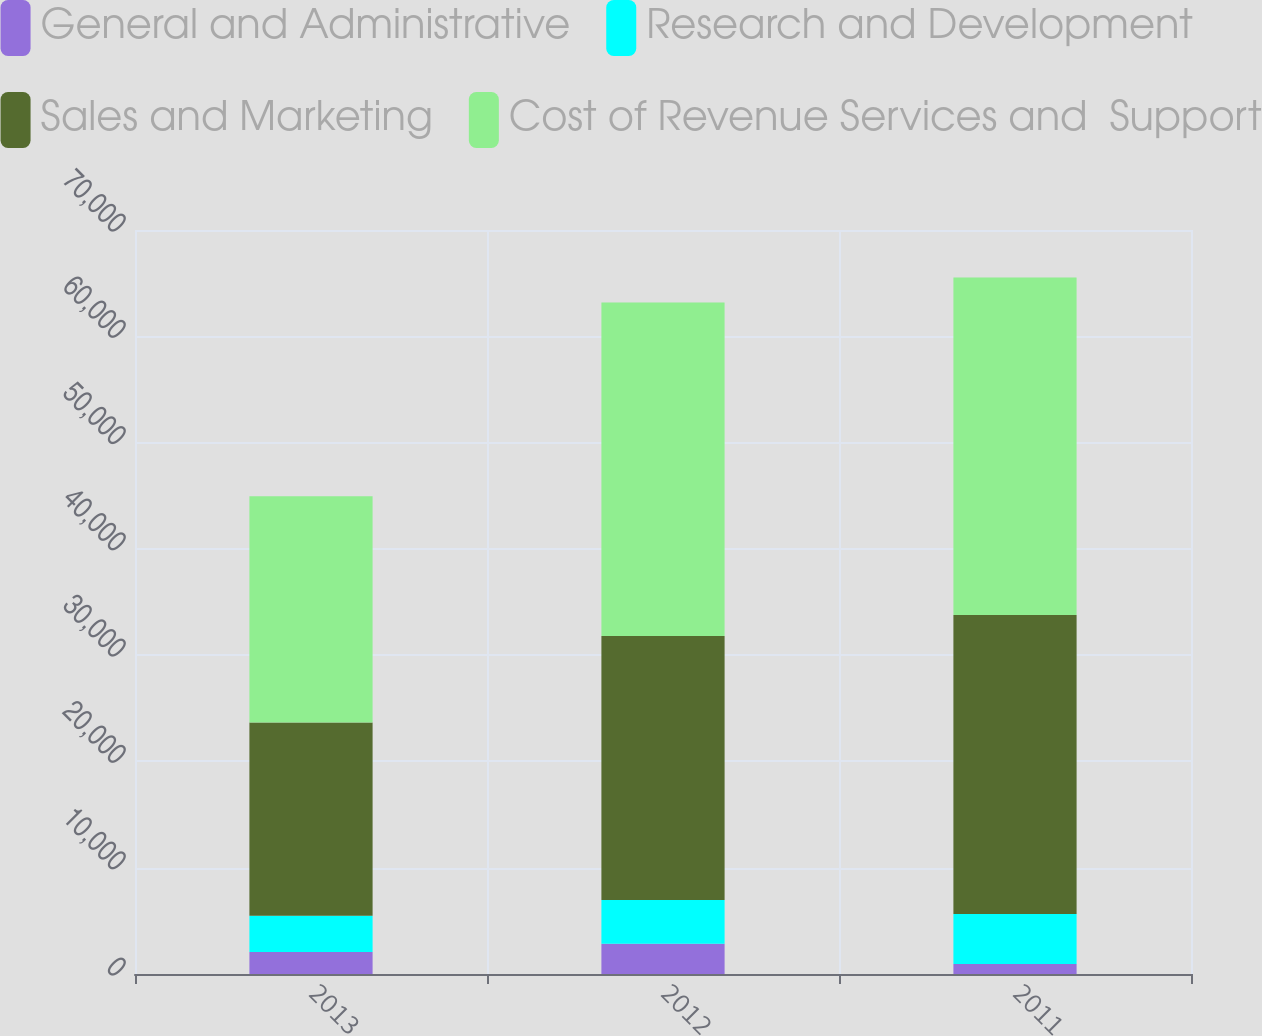Convert chart. <chart><loc_0><loc_0><loc_500><loc_500><stacked_bar_chart><ecel><fcel>2013<fcel>2012<fcel>2011<nl><fcel>General and Administrative<fcel>2059<fcel>2840<fcel>936<nl><fcel>Research and Development<fcel>3413<fcel>4130<fcel>4716<nl><fcel>Sales and Marketing<fcel>18188<fcel>24823<fcel>28132<nl><fcel>Cost of Revenue Services and  Support<fcel>21283<fcel>31379<fcel>31754<nl></chart> 